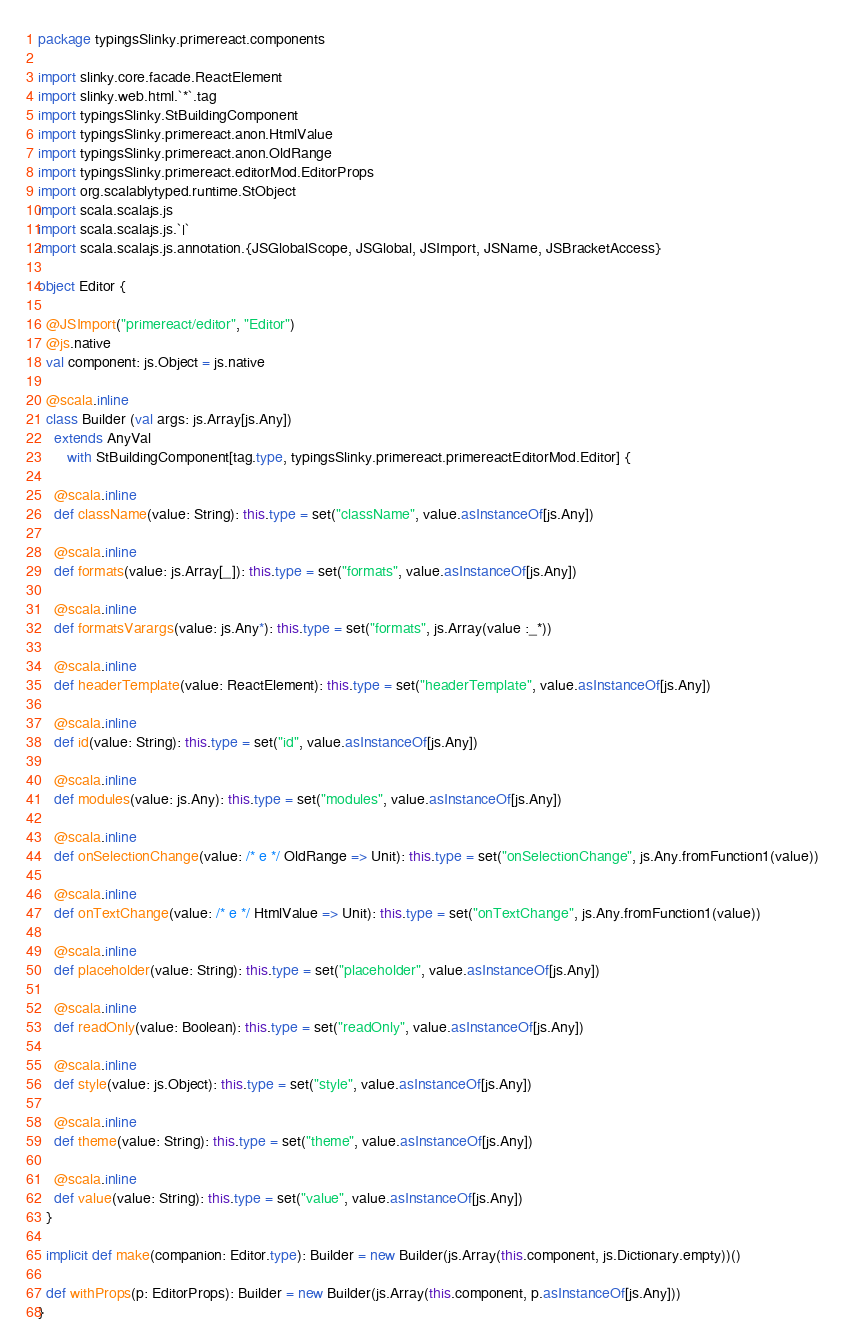<code> <loc_0><loc_0><loc_500><loc_500><_Scala_>package typingsSlinky.primereact.components

import slinky.core.facade.ReactElement
import slinky.web.html.`*`.tag
import typingsSlinky.StBuildingComponent
import typingsSlinky.primereact.anon.HtmlValue
import typingsSlinky.primereact.anon.OldRange
import typingsSlinky.primereact.editorMod.EditorProps
import org.scalablytyped.runtime.StObject
import scala.scalajs.js
import scala.scalajs.js.`|`
import scala.scalajs.js.annotation.{JSGlobalScope, JSGlobal, JSImport, JSName, JSBracketAccess}

object Editor {
  
  @JSImport("primereact/editor", "Editor")
  @js.native
  val component: js.Object = js.native
  
  @scala.inline
  class Builder (val args: js.Array[js.Any])
    extends AnyVal
       with StBuildingComponent[tag.type, typingsSlinky.primereact.primereactEditorMod.Editor] {
    
    @scala.inline
    def className(value: String): this.type = set("className", value.asInstanceOf[js.Any])
    
    @scala.inline
    def formats(value: js.Array[_]): this.type = set("formats", value.asInstanceOf[js.Any])
    
    @scala.inline
    def formatsVarargs(value: js.Any*): this.type = set("formats", js.Array(value :_*))
    
    @scala.inline
    def headerTemplate(value: ReactElement): this.type = set("headerTemplate", value.asInstanceOf[js.Any])
    
    @scala.inline
    def id(value: String): this.type = set("id", value.asInstanceOf[js.Any])
    
    @scala.inline
    def modules(value: js.Any): this.type = set("modules", value.asInstanceOf[js.Any])
    
    @scala.inline
    def onSelectionChange(value: /* e */ OldRange => Unit): this.type = set("onSelectionChange", js.Any.fromFunction1(value))
    
    @scala.inline
    def onTextChange(value: /* e */ HtmlValue => Unit): this.type = set("onTextChange", js.Any.fromFunction1(value))
    
    @scala.inline
    def placeholder(value: String): this.type = set("placeholder", value.asInstanceOf[js.Any])
    
    @scala.inline
    def readOnly(value: Boolean): this.type = set("readOnly", value.asInstanceOf[js.Any])
    
    @scala.inline
    def style(value: js.Object): this.type = set("style", value.asInstanceOf[js.Any])
    
    @scala.inline
    def theme(value: String): this.type = set("theme", value.asInstanceOf[js.Any])
    
    @scala.inline
    def value(value: String): this.type = set("value", value.asInstanceOf[js.Any])
  }
  
  implicit def make(companion: Editor.type): Builder = new Builder(js.Array(this.component, js.Dictionary.empty))()
  
  def withProps(p: EditorProps): Builder = new Builder(js.Array(this.component, p.asInstanceOf[js.Any]))
}
</code> 